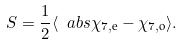<formula> <loc_0><loc_0><loc_500><loc_500>S = \frac { 1 } { 2 } \langle \ a b s { \chi _ { 7 , \text {e} } - \chi _ { 7 , \text {o} } } \rangle .</formula> 